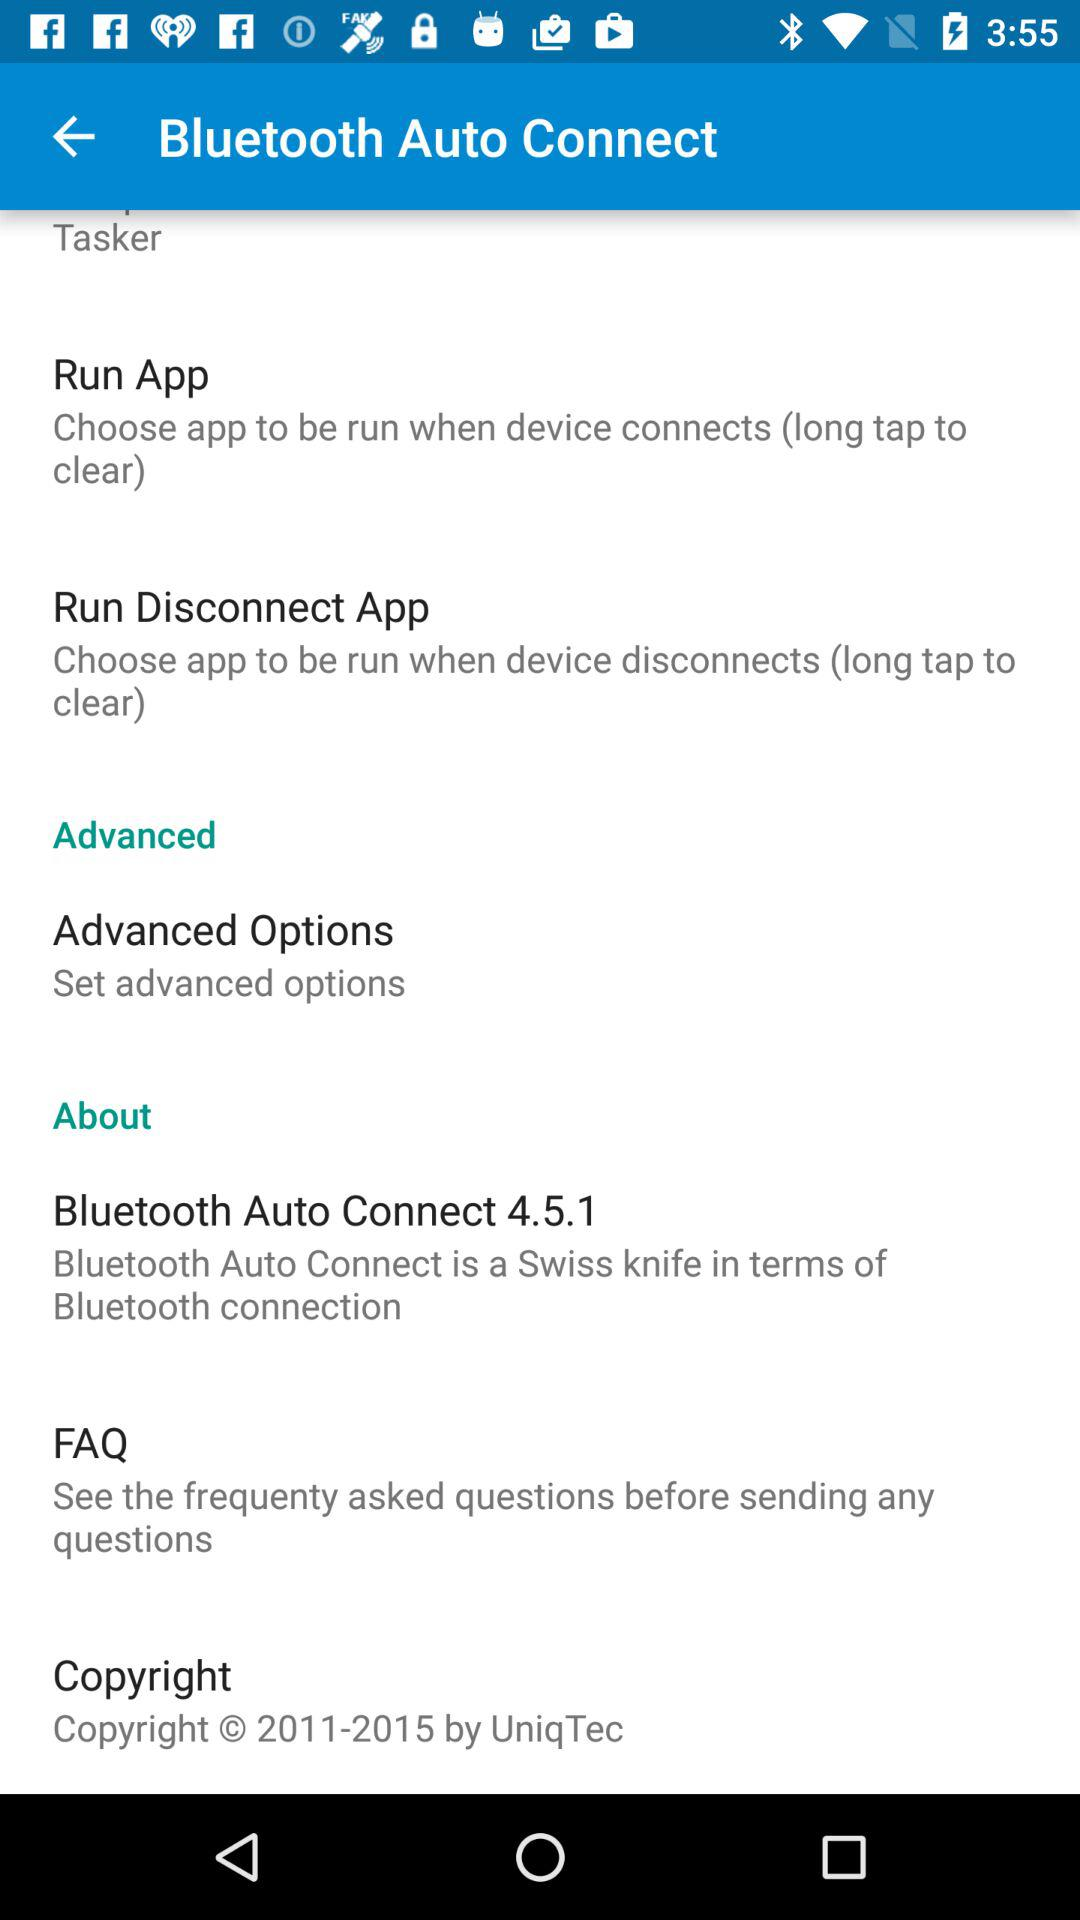What is the year of copyright of the application? The years of copyright are from 2011 to 2015. 